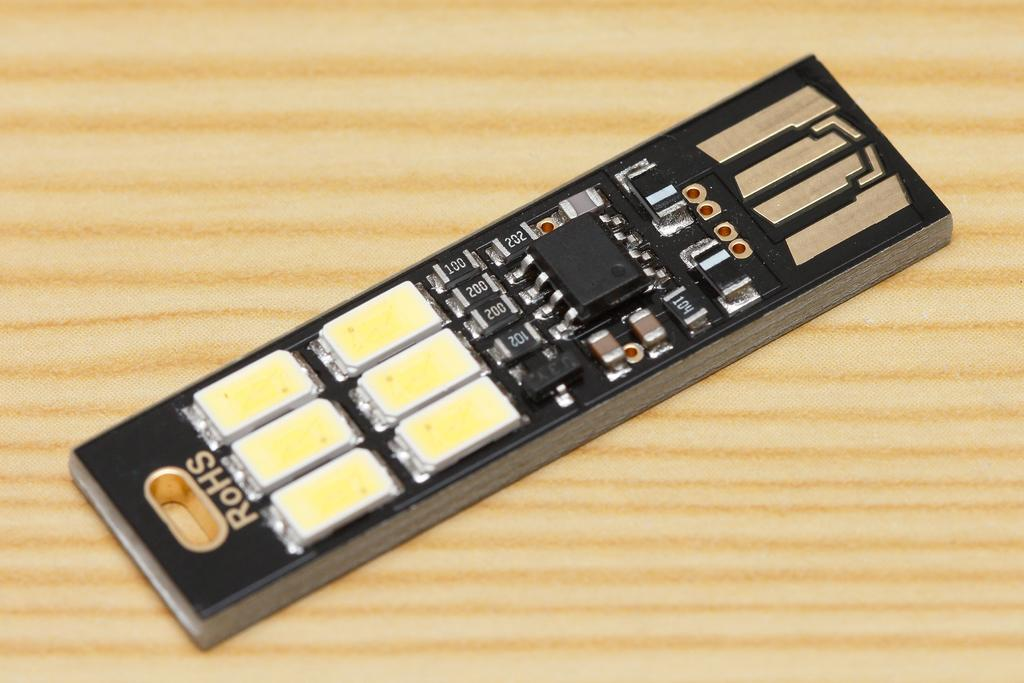<image>
Share a concise interpretation of the image provided. A RoHS computer chip on a wooden surface. 